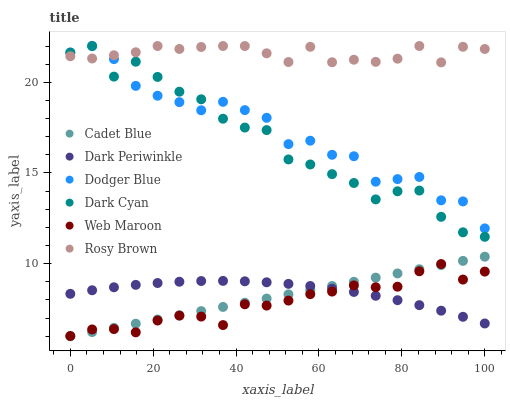Does Web Maroon have the minimum area under the curve?
Answer yes or no. Yes. Does Rosy Brown have the maximum area under the curve?
Answer yes or no. Yes. Does Rosy Brown have the minimum area under the curve?
Answer yes or no. No. Does Web Maroon have the maximum area under the curve?
Answer yes or no. No. Is Cadet Blue the smoothest?
Answer yes or no. Yes. Is Dodger Blue the roughest?
Answer yes or no. Yes. Is Rosy Brown the smoothest?
Answer yes or no. No. Is Rosy Brown the roughest?
Answer yes or no. No. Does Cadet Blue have the lowest value?
Answer yes or no. Yes. Does Web Maroon have the lowest value?
Answer yes or no. No. Does Dark Cyan have the highest value?
Answer yes or no. Yes. Does Web Maroon have the highest value?
Answer yes or no. No. Is Cadet Blue less than Dodger Blue?
Answer yes or no. Yes. Is Dark Cyan greater than Dark Periwinkle?
Answer yes or no. Yes. Does Rosy Brown intersect Dark Cyan?
Answer yes or no. Yes. Is Rosy Brown less than Dark Cyan?
Answer yes or no. No. Is Rosy Brown greater than Dark Cyan?
Answer yes or no. No. Does Cadet Blue intersect Dodger Blue?
Answer yes or no. No. 